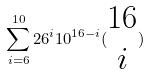<formula> <loc_0><loc_0><loc_500><loc_500>\sum _ { i = 6 } ^ { 1 0 } 2 6 ^ { i } 1 0 ^ { 1 6 - i } ( \begin{matrix} 1 6 \\ i \end{matrix} )</formula> 